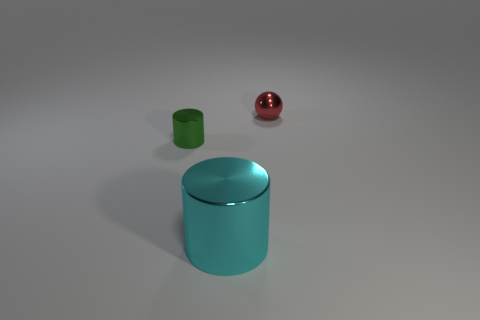Add 2 large objects. How many objects exist? 5 Subtract all cylinders. How many objects are left? 1 Subtract all metallic things. Subtract all brown rubber cubes. How many objects are left? 0 Add 1 big metallic cylinders. How many big metallic cylinders are left? 2 Add 1 small cyan blocks. How many small cyan blocks exist? 1 Subtract 1 red balls. How many objects are left? 2 